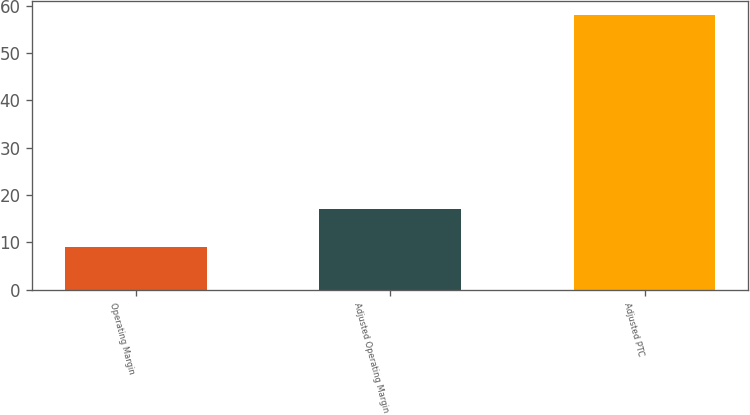Convert chart to OTSL. <chart><loc_0><loc_0><loc_500><loc_500><bar_chart><fcel>Operating Margin<fcel>Adjusted Operating Margin<fcel>Adjusted PTC<nl><fcel>9<fcel>17<fcel>58<nl></chart> 